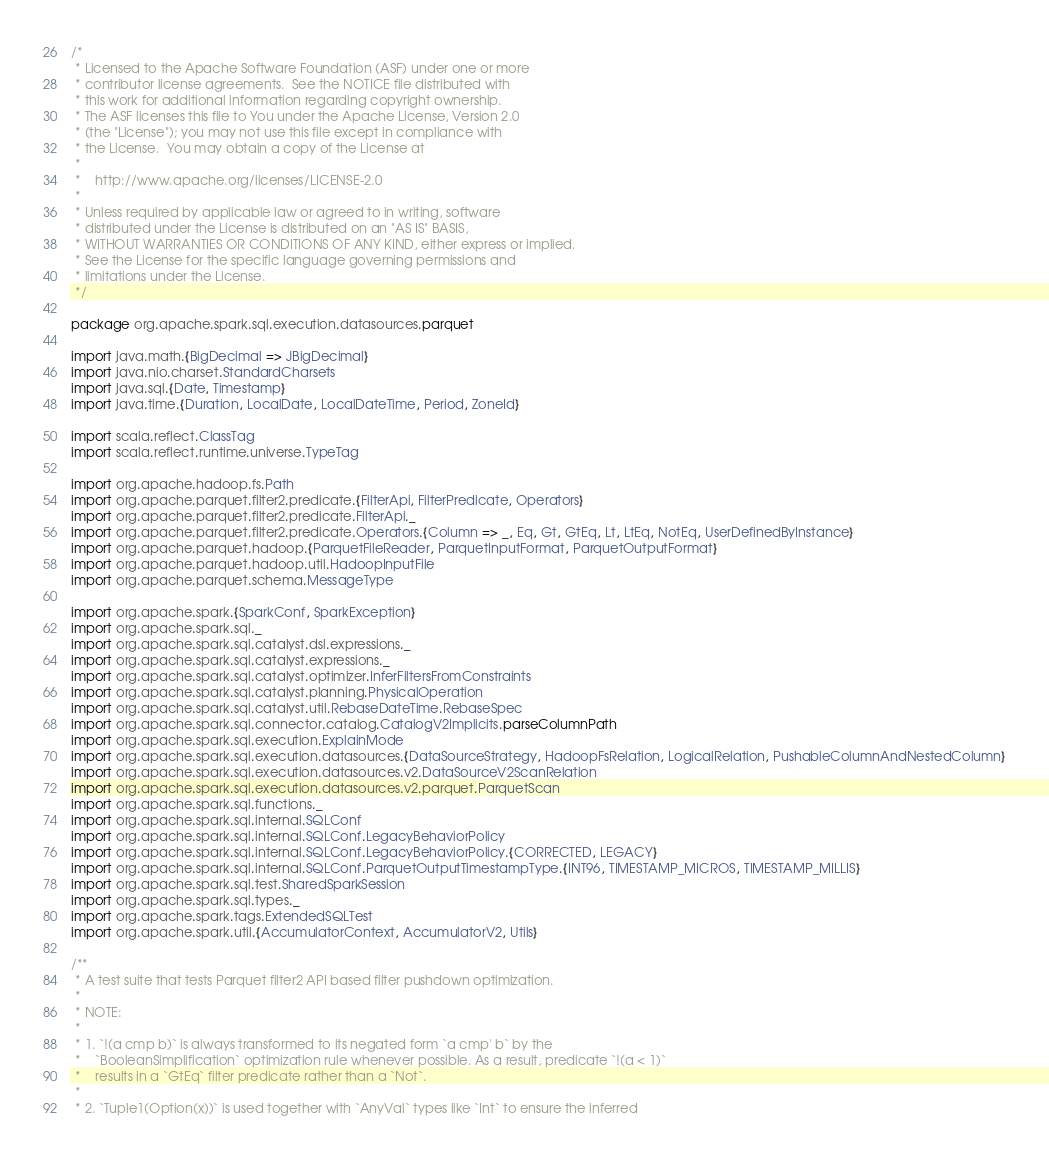<code> <loc_0><loc_0><loc_500><loc_500><_Scala_>/*
 * Licensed to the Apache Software Foundation (ASF) under one or more
 * contributor license agreements.  See the NOTICE file distributed with
 * this work for additional information regarding copyright ownership.
 * The ASF licenses this file to You under the Apache License, Version 2.0
 * (the "License"); you may not use this file except in compliance with
 * the License.  You may obtain a copy of the License at
 *
 *    http://www.apache.org/licenses/LICENSE-2.0
 *
 * Unless required by applicable law or agreed to in writing, software
 * distributed under the License is distributed on an "AS IS" BASIS,
 * WITHOUT WARRANTIES OR CONDITIONS OF ANY KIND, either express or implied.
 * See the License for the specific language governing permissions and
 * limitations under the License.
 */

package org.apache.spark.sql.execution.datasources.parquet

import java.math.{BigDecimal => JBigDecimal}
import java.nio.charset.StandardCharsets
import java.sql.{Date, Timestamp}
import java.time.{Duration, LocalDate, LocalDateTime, Period, ZoneId}

import scala.reflect.ClassTag
import scala.reflect.runtime.universe.TypeTag

import org.apache.hadoop.fs.Path
import org.apache.parquet.filter2.predicate.{FilterApi, FilterPredicate, Operators}
import org.apache.parquet.filter2.predicate.FilterApi._
import org.apache.parquet.filter2.predicate.Operators.{Column => _, Eq, Gt, GtEq, Lt, LtEq, NotEq, UserDefinedByInstance}
import org.apache.parquet.hadoop.{ParquetFileReader, ParquetInputFormat, ParquetOutputFormat}
import org.apache.parquet.hadoop.util.HadoopInputFile
import org.apache.parquet.schema.MessageType

import org.apache.spark.{SparkConf, SparkException}
import org.apache.spark.sql._
import org.apache.spark.sql.catalyst.dsl.expressions._
import org.apache.spark.sql.catalyst.expressions._
import org.apache.spark.sql.catalyst.optimizer.InferFiltersFromConstraints
import org.apache.spark.sql.catalyst.planning.PhysicalOperation
import org.apache.spark.sql.catalyst.util.RebaseDateTime.RebaseSpec
import org.apache.spark.sql.connector.catalog.CatalogV2Implicits.parseColumnPath
import org.apache.spark.sql.execution.ExplainMode
import org.apache.spark.sql.execution.datasources.{DataSourceStrategy, HadoopFsRelation, LogicalRelation, PushableColumnAndNestedColumn}
import org.apache.spark.sql.execution.datasources.v2.DataSourceV2ScanRelation
import org.apache.spark.sql.execution.datasources.v2.parquet.ParquetScan
import org.apache.spark.sql.functions._
import org.apache.spark.sql.internal.SQLConf
import org.apache.spark.sql.internal.SQLConf.LegacyBehaviorPolicy
import org.apache.spark.sql.internal.SQLConf.LegacyBehaviorPolicy.{CORRECTED, LEGACY}
import org.apache.spark.sql.internal.SQLConf.ParquetOutputTimestampType.{INT96, TIMESTAMP_MICROS, TIMESTAMP_MILLIS}
import org.apache.spark.sql.test.SharedSparkSession
import org.apache.spark.sql.types._
import org.apache.spark.tags.ExtendedSQLTest
import org.apache.spark.util.{AccumulatorContext, AccumulatorV2, Utils}

/**
 * A test suite that tests Parquet filter2 API based filter pushdown optimization.
 *
 * NOTE:
 *
 * 1. `!(a cmp b)` is always transformed to its negated form `a cmp' b` by the
 *    `BooleanSimplification` optimization rule whenever possible. As a result, predicate `!(a < 1)`
 *    results in a `GtEq` filter predicate rather than a `Not`.
 *
 * 2. `Tuple1(Option(x))` is used together with `AnyVal` types like `Int` to ensure the inferred</code> 